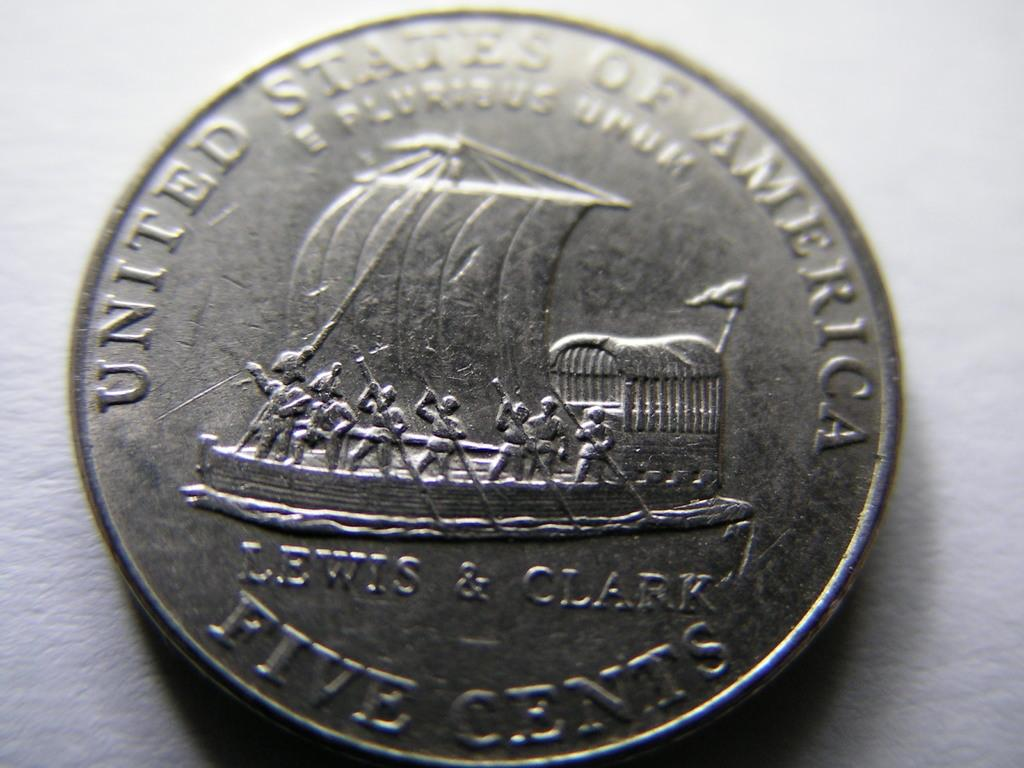<image>
Give a short and clear explanation of the subsequent image. The coin shown is worth five cents in America. 